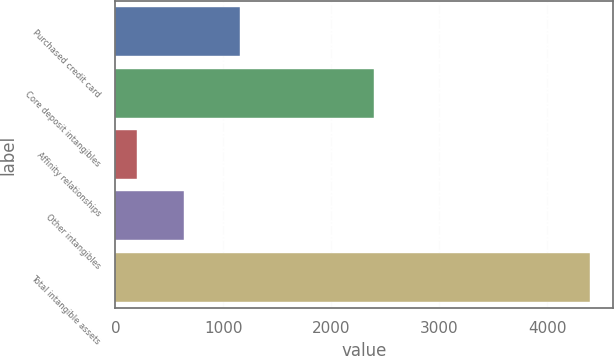Convert chart to OTSL. <chart><loc_0><loc_0><loc_500><loc_500><bar_chart><fcel>Purchased credit card<fcel>Core deposit intangibles<fcel>Affinity relationships<fcel>Other intangibles<fcel>Total intangible assets<nl><fcel>1159<fcel>2396<fcel>205<fcel>633<fcel>4393<nl></chart> 